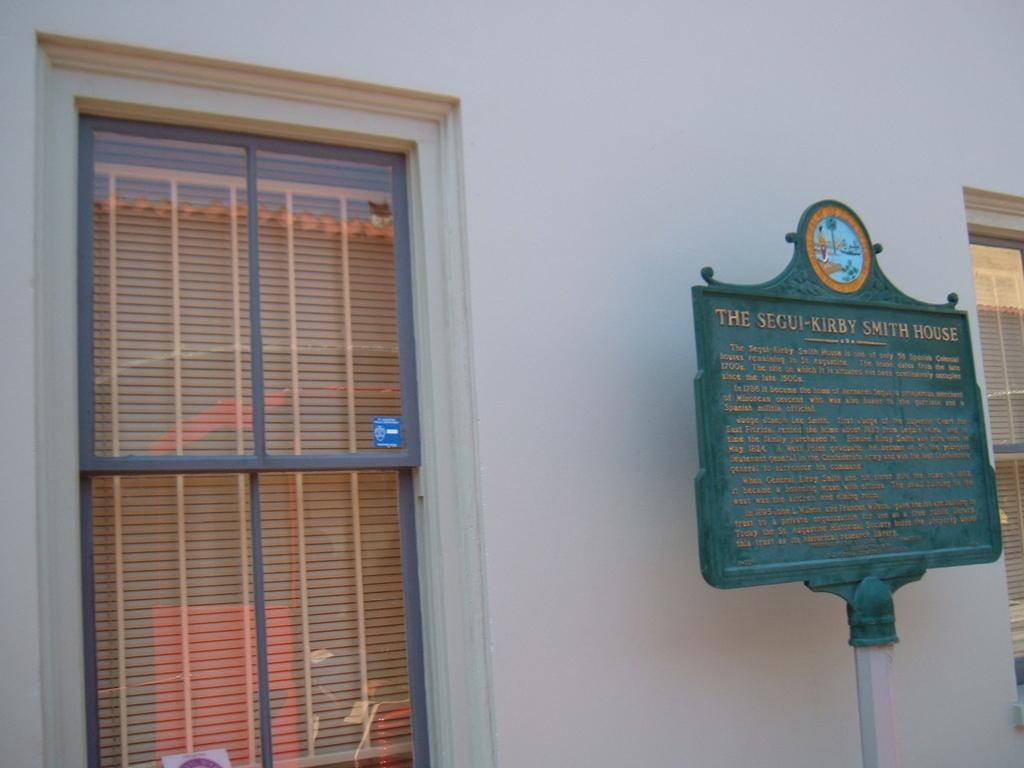<image>
Provide a brief description of the given image. An information sign informing the name of a building as the Segui-Kirby Smith House. 